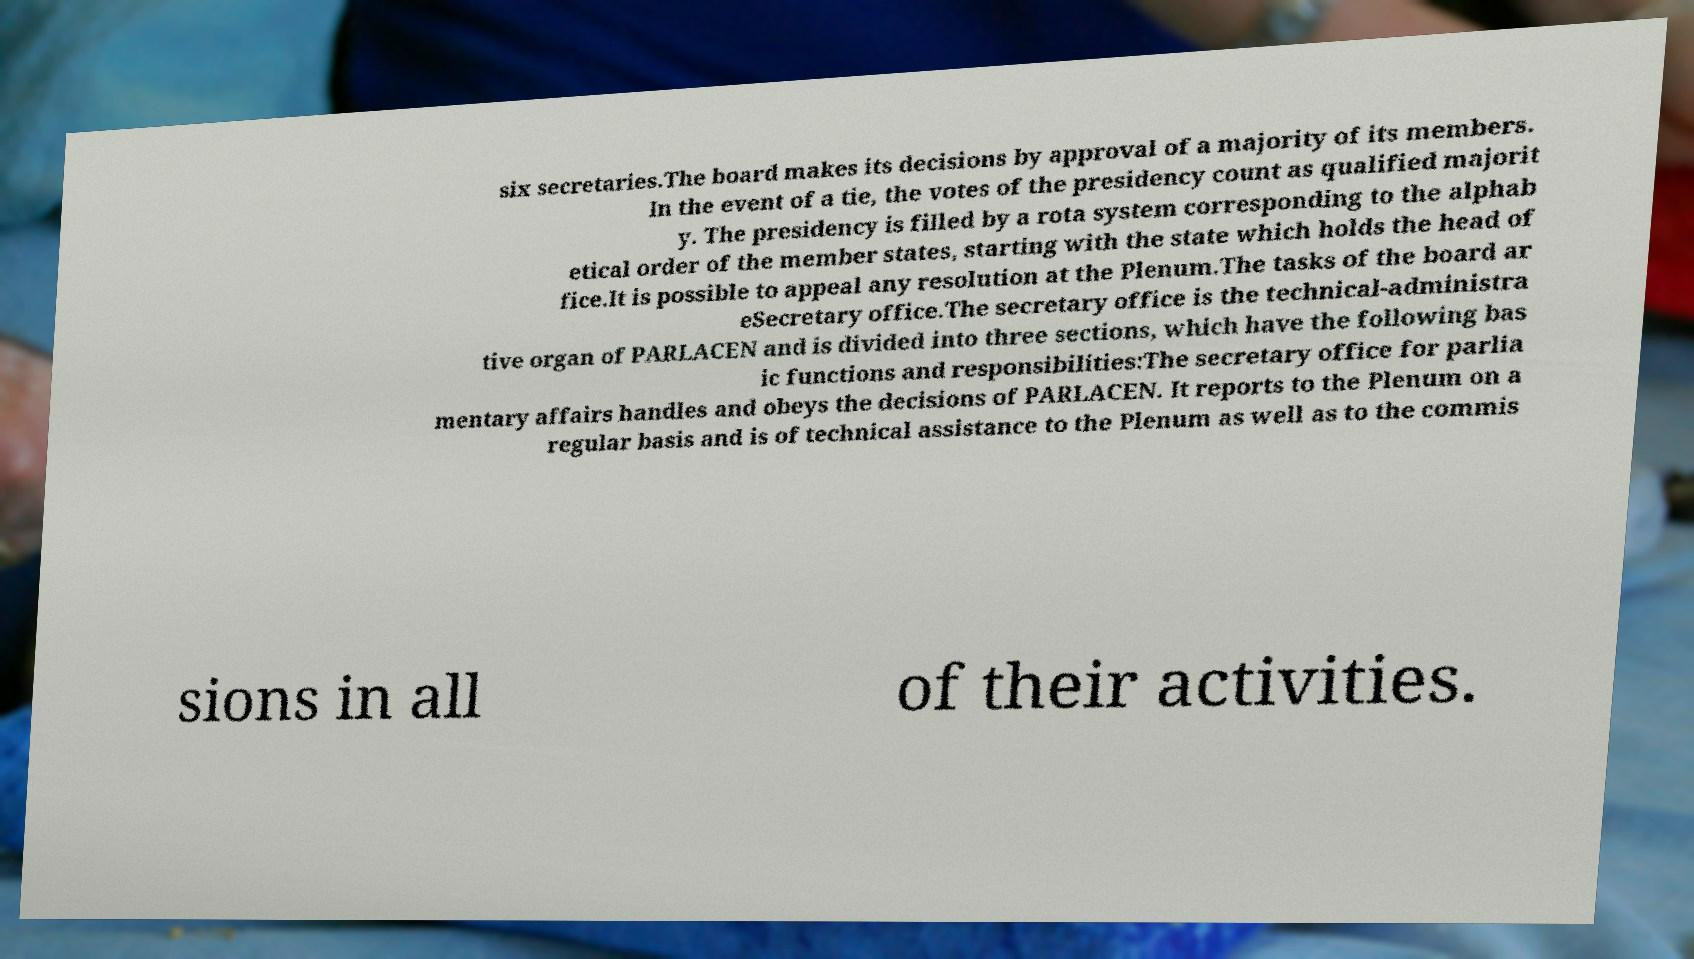Could you assist in decoding the text presented in this image and type it out clearly? six secretaries.The board makes its decisions by approval of a majority of its members. In the event of a tie, the votes of the presidency count as qualified majorit y. The presidency is filled by a rota system corresponding to the alphab etical order of the member states, starting with the state which holds the head of fice.It is possible to appeal any resolution at the Plenum.The tasks of the board ar eSecretary office.The secretary office is the technical-administra tive organ of PARLACEN and is divided into three sections, which have the following bas ic functions and responsibilities:The secretary office for parlia mentary affairs handles and obeys the decisions of PARLACEN. It reports to the Plenum on a regular basis and is of technical assistance to the Plenum as well as to the commis sions in all of their activities. 